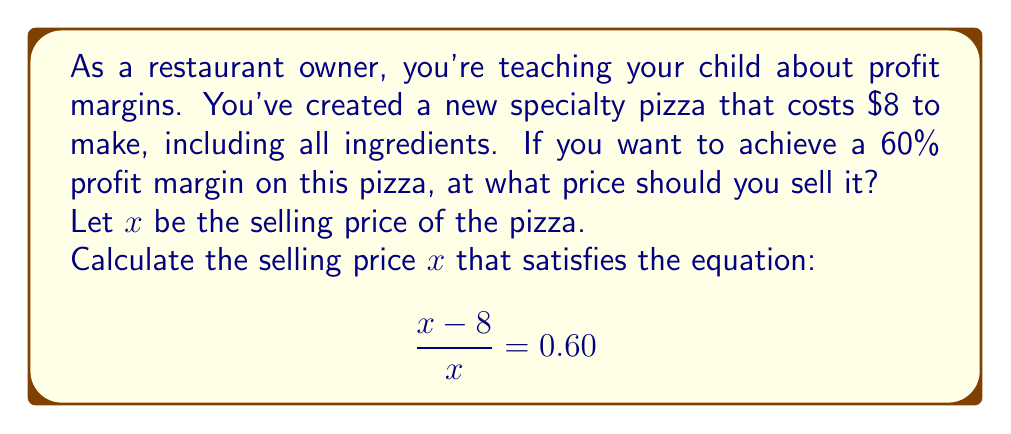Help me with this question. Let's break this down step-by-step:

1) The profit margin is calculated as:

   $$\text{Profit Margin} = \frac{\text{Revenue} - \text{Cost}}{\text{Revenue}}$$

2) We're given that the cost is $8 and we want the profit margin to be 60% or 0.60.

3) Let's substitute these into our equation:

   $$\frac{x - 8}{x} = 0.60$$

4) To solve this, let's first multiply both sides by $x$:

   $$(x - 8) = 0.60x$$

5) Distribute on the right side:

   $$x - 8 = 0.60x$$

6) Subtract $0.60x$ from both sides:

   $$0.40x - 8 = 0$$

7) Add 8 to both sides:

   $$0.40x = 8$$

8) Finally, divide both sides by 0.40:

   $$x = \frac{8}{0.40} = 20$$

Therefore, to achieve a 60% profit margin, you should sell the pizza for $20.

Let's verify:
- Cost = $8
- Revenue = $20
- Profit = Revenue - Cost = $20 - $8 = $12
- Profit Margin = $12 / $20 = 0.60 or 60%
Answer: $20 